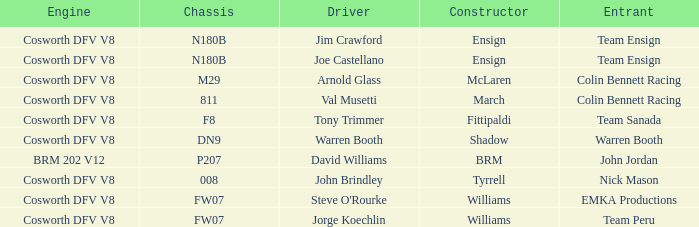Who put together the vehicle of jim crawford? Ensign. 